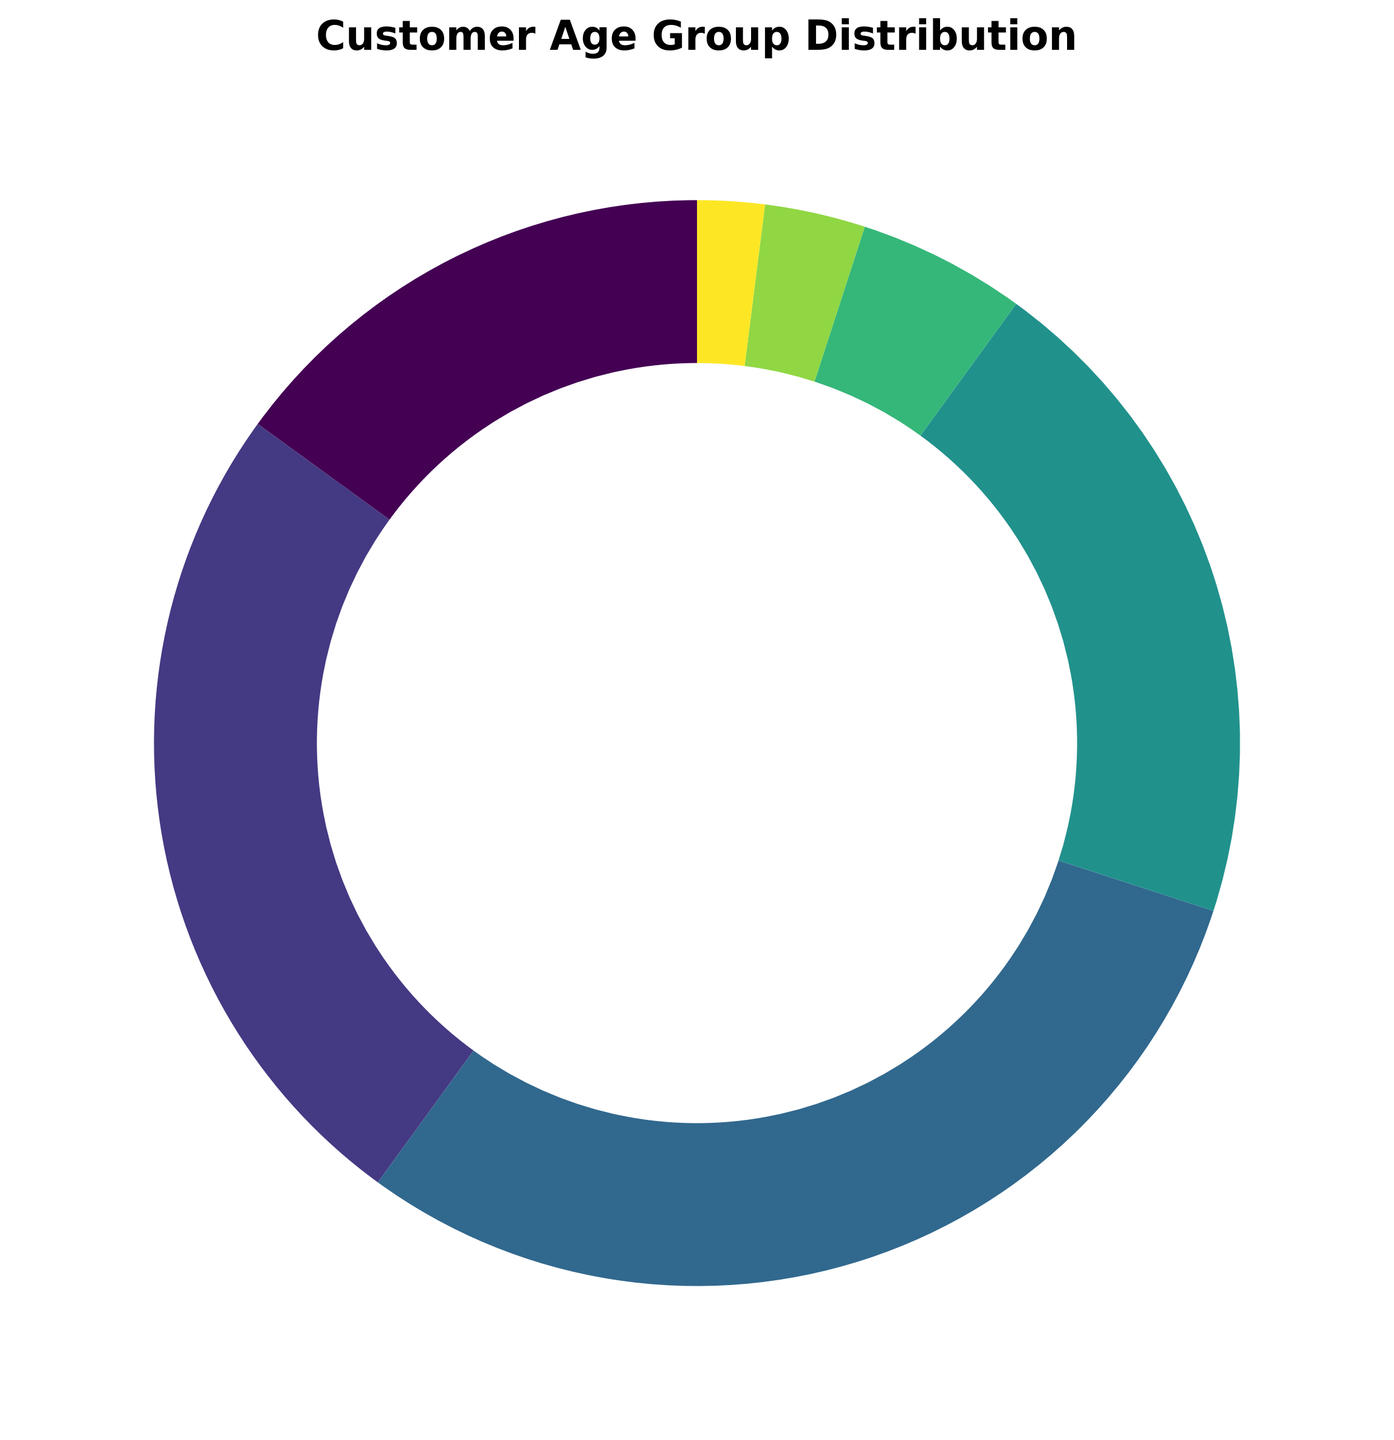What is the largest age group in the distribution? By examining the pie chart, the largest section represents the 25-34 age group. This is easily identifiable as it occupies the largest percentage area.
Answer: 25-34 Which age group has the smallest percentage of customers? Looking at the smallest slice of the pie chart, the 65 and above age group occupies the smallest portion.
Answer: 65 and above How much larger is the 25-34 age group compared to the 55-64 age group? The 25-34 age group constitutes 30% of the customer base, while the 55-64 age group constitutes 3%. The difference can be computed as 30% - 3% = 27%.
Answer: 27% What is the combined percentage of customers aged 35-44 and 45-54? Adding the percentages for the 35-44 age group (20%) and the 45-54 age group (5%) gives a total of 20% + 5% = 25%.
Answer: 25% How does the percentage of customers under 18 compare to those aged 18-24? The percentage for customers under 18 is 15%, while for those aged 18-24 it is 25%. This shows the 18-24 age group is larger by 25% - 15% = 10%.
Answer: 10% Which age group occupies the second-largest segment in the pie chart? Analyzing the sections, the 18-24 age group is the second largest with 25%, following the largest group, 25-34 with 30%.
Answer: 18-24 What is the visual color representation of the 45-54 age group in the pie chart? The pie chart uses a spectrum of colors from the viridis palette. According to this palette, the 45-54 age group is represented in a lighter shade compared to 55-64 and 65 and above, yet darker than the younger age groups. Exact color descriptions might vary visually, but it's typically a mid-range lighter tone.
Answer: Light mid-range color If you remove the two smallest age groups, what would be the new total percentage of the remaining groups? Removing the percentages for 55-64 and 65 and above (3% and 2% respectively) from 100% leaves 100% - 3% - 2% = 95%.
Answer: 95% What is the average percentage of the age groups that are 35 and above? The percentages for the age groups 35-44, 45-54, 55-64, and 65 and above are 20%, 5%, 3%, and 2% respectively. Summing these gives 20% + 5% + 3% + 2% = 30%. There are 4 groups, so the average is 30% / 4 = 7.5%.
Answer: 7.5% What percentage of customers are younger than 35 years old? Adding the percentages for the age groups Under 18, 18-24, and 25-34 results in 15% + 25% + 30% = 70%.
Answer: 70% 